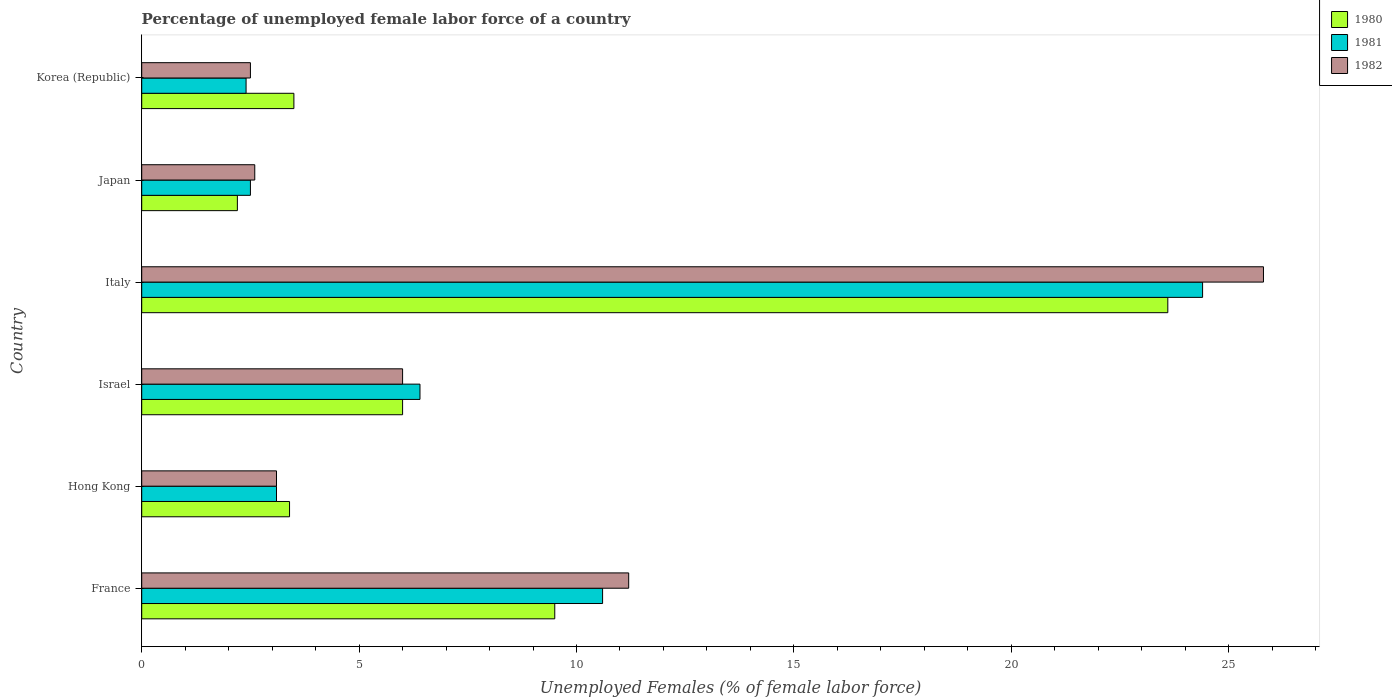How many different coloured bars are there?
Offer a very short reply. 3. How many groups of bars are there?
Provide a succinct answer. 6. What is the label of the 5th group of bars from the top?
Give a very brief answer. Hong Kong. In how many cases, is the number of bars for a given country not equal to the number of legend labels?
Ensure brevity in your answer.  0. Across all countries, what is the maximum percentage of unemployed female labor force in 1981?
Make the answer very short. 24.4. Across all countries, what is the minimum percentage of unemployed female labor force in 1981?
Your answer should be compact. 2.4. What is the total percentage of unemployed female labor force in 1980 in the graph?
Ensure brevity in your answer.  48.2. What is the difference between the percentage of unemployed female labor force in 1980 in Japan and that in Korea (Republic)?
Provide a succinct answer. -1.3. What is the difference between the percentage of unemployed female labor force in 1982 in Italy and the percentage of unemployed female labor force in 1981 in Hong Kong?
Offer a very short reply. 22.7. What is the average percentage of unemployed female labor force in 1981 per country?
Your response must be concise. 8.23. What is the difference between the percentage of unemployed female labor force in 1982 and percentage of unemployed female labor force in 1980 in Hong Kong?
Offer a terse response. -0.3. In how many countries, is the percentage of unemployed female labor force in 1980 greater than 18 %?
Your answer should be compact. 1. What is the ratio of the percentage of unemployed female labor force in 1980 in Hong Kong to that in Italy?
Your response must be concise. 0.14. Is the percentage of unemployed female labor force in 1980 in Japan less than that in Korea (Republic)?
Keep it short and to the point. Yes. Is the difference between the percentage of unemployed female labor force in 1982 in Italy and Korea (Republic) greater than the difference between the percentage of unemployed female labor force in 1980 in Italy and Korea (Republic)?
Make the answer very short. Yes. What is the difference between the highest and the second highest percentage of unemployed female labor force in 1982?
Give a very brief answer. 14.6. What is the difference between the highest and the lowest percentage of unemployed female labor force in 1980?
Your answer should be very brief. 21.4. In how many countries, is the percentage of unemployed female labor force in 1982 greater than the average percentage of unemployed female labor force in 1982 taken over all countries?
Your response must be concise. 2. What does the 1st bar from the top in France represents?
Provide a succinct answer. 1982. Is it the case that in every country, the sum of the percentage of unemployed female labor force in 1981 and percentage of unemployed female labor force in 1980 is greater than the percentage of unemployed female labor force in 1982?
Provide a succinct answer. Yes. Are the values on the major ticks of X-axis written in scientific E-notation?
Provide a short and direct response. No. Does the graph contain grids?
Provide a short and direct response. No. Where does the legend appear in the graph?
Give a very brief answer. Top right. What is the title of the graph?
Provide a succinct answer. Percentage of unemployed female labor force of a country. Does "2000" appear as one of the legend labels in the graph?
Your answer should be compact. No. What is the label or title of the X-axis?
Make the answer very short. Unemployed Females (% of female labor force). What is the label or title of the Y-axis?
Provide a short and direct response. Country. What is the Unemployed Females (% of female labor force) in 1980 in France?
Ensure brevity in your answer.  9.5. What is the Unemployed Females (% of female labor force) in 1981 in France?
Offer a very short reply. 10.6. What is the Unemployed Females (% of female labor force) of 1982 in France?
Your answer should be compact. 11.2. What is the Unemployed Females (% of female labor force) in 1980 in Hong Kong?
Keep it short and to the point. 3.4. What is the Unemployed Females (% of female labor force) of 1981 in Hong Kong?
Make the answer very short. 3.1. What is the Unemployed Females (% of female labor force) in 1982 in Hong Kong?
Your answer should be very brief. 3.1. What is the Unemployed Females (% of female labor force) in 1981 in Israel?
Your answer should be very brief. 6.4. What is the Unemployed Females (% of female labor force) of 1982 in Israel?
Your answer should be very brief. 6. What is the Unemployed Females (% of female labor force) in 1980 in Italy?
Give a very brief answer. 23.6. What is the Unemployed Females (% of female labor force) of 1981 in Italy?
Provide a short and direct response. 24.4. What is the Unemployed Females (% of female labor force) of 1982 in Italy?
Give a very brief answer. 25.8. What is the Unemployed Females (% of female labor force) of 1980 in Japan?
Your answer should be very brief. 2.2. What is the Unemployed Females (% of female labor force) of 1982 in Japan?
Offer a terse response. 2.6. What is the Unemployed Females (% of female labor force) of 1980 in Korea (Republic)?
Give a very brief answer. 3.5. What is the Unemployed Females (% of female labor force) in 1981 in Korea (Republic)?
Provide a succinct answer. 2.4. Across all countries, what is the maximum Unemployed Females (% of female labor force) in 1980?
Make the answer very short. 23.6. Across all countries, what is the maximum Unemployed Females (% of female labor force) of 1981?
Offer a very short reply. 24.4. Across all countries, what is the maximum Unemployed Females (% of female labor force) of 1982?
Ensure brevity in your answer.  25.8. Across all countries, what is the minimum Unemployed Females (% of female labor force) in 1980?
Your answer should be very brief. 2.2. Across all countries, what is the minimum Unemployed Females (% of female labor force) of 1981?
Ensure brevity in your answer.  2.4. Across all countries, what is the minimum Unemployed Females (% of female labor force) in 1982?
Ensure brevity in your answer.  2.5. What is the total Unemployed Females (% of female labor force) of 1980 in the graph?
Keep it short and to the point. 48.2. What is the total Unemployed Females (% of female labor force) of 1981 in the graph?
Offer a very short reply. 49.4. What is the total Unemployed Females (% of female labor force) of 1982 in the graph?
Your response must be concise. 51.2. What is the difference between the Unemployed Females (% of female labor force) of 1982 in France and that in Hong Kong?
Provide a short and direct response. 8.1. What is the difference between the Unemployed Females (% of female labor force) of 1981 in France and that in Israel?
Your response must be concise. 4.2. What is the difference between the Unemployed Females (% of female labor force) in 1980 in France and that in Italy?
Provide a short and direct response. -14.1. What is the difference between the Unemployed Females (% of female labor force) of 1981 in France and that in Italy?
Provide a short and direct response. -13.8. What is the difference between the Unemployed Females (% of female labor force) of 1982 in France and that in Italy?
Give a very brief answer. -14.6. What is the difference between the Unemployed Females (% of female labor force) of 1981 in France and that in Japan?
Offer a terse response. 8.1. What is the difference between the Unemployed Females (% of female labor force) in 1980 in France and that in Korea (Republic)?
Offer a very short reply. 6. What is the difference between the Unemployed Females (% of female labor force) in 1981 in France and that in Korea (Republic)?
Ensure brevity in your answer.  8.2. What is the difference between the Unemployed Females (% of female labor force) of 1980 in Hong Kong and that in Israel?
Your response must be concise. -2.6. What is the difference between the Unemployed Females (% of female labor force) of 1980 in Hong Kong and that in Italy?
Offer a very short reply. -20.2. What is the difference between the Unemployed Females (% of female labor force) in 1981 in Hong Kong and that in Italy?
Your answer should be very brief. -21.3. What is the difference between the Unemployed Females (% of female labor force) in 1982 in Hong Kong and that in Italy?
Make the answer very short. -22.7. What is the difference between the Unemployed Females (% of female labor force) of 1980 in Hong Kong and that in Japan?
Offer a terse response. 1.2. What is the difference between the Unemployed Females (% of female labor force) of 1981 in Hong Kong and that in Korea (Republic)?
Keep it short and to the point. 0.7. What is the difference between the Unemployed Females (% of female labor force) of 1982 in Hong Kong and that in Korea (Republic)?
Make the answer very short. 0.6. What is the difference between the Unemployed Females (% of female labor force) of 1980 in Israel and that in Italy?
Your response must be concise. -17.6. What is the difference between the Unemployed Females (% of female labor force) in 1981 in Israel and that in Italy?
Make the answer very short. -18. What is the difference between the Unemployed Females (% of female labor force) in 1982 in Israel and that in Italy?
Ensure brevity in your answer.  -19.8. What is the difference between the Unemployed Females (% of female labor force) of 1980 in Israel and that in Japan?
Ensure brevity in your answer.  3.8. What is the difference between the Unemployed Females (% of female labor force) of 1982 in Israel and that in Japan?
Provide a succinct answer. 3.4. What is the difference between the Unemployed Females (% of female labor force) in 1980 in Israel and that in Korea (Republic)?
Make the answer very short. 2.5. What is the difference between the Unemployed Females (% of female labor force) of 1982 in Israel and that in Korea (Republic)?
Make the answer very short. 3.5. What is the difference between the Unemployed Females (% of female labor force) of 1980 in Italy and that in Japan?
Provide a succinct answer. 21.4. What is the difference between the Unemployed Females (% of female labor force) in 1981 in Italy and that in Japan?
Provide a succinct answer. 21.9. What is the difference between the Unemployed Females (% of female labor force) of 1982 in Italy and that in Japan?
Your answer should be very brief. 23.2. What is the difference between the Unemployed Females (% of female labor force) in 1980 in Italy and that in Korea (Republic)?
Make the answer very short. 20.1. What is the difference between the Unemployed Females (% of female labor force) in 1982 in Italy and that in Korea (Republic)?
Ensure brevity in your answer.  23.3. What is the difference between the Unemployed Females (% of female labor force) in 1980 in Japan and that in Korea (Republic)?
Offer a very short reply. -1.3. What is the difference between the Unemployed Females (% of female labor force) of 1981 in Japan and that in Korea (Republic)?
Your answer should be compact. 0.1. What is the difference between the Unemployed Females (% of female labor force) of 1980 in France and the Unemployed Females (% of female labor force) of 1982 in Hong Kong?
Offer a terse response. 6.4. What is the difference between the Unemployed Females (% of female labor force) in 1981 in France and the Unemployed Females (% of female labor force) in 1982 in Hong Kong?
Your answer should be very brief. 7.5. What is the difference between the Unemployed Females (% of female labor force) in 1980 in France and the Unemployed Females (% of female labor force) in 1981 in Italy?
Your answer should be compact. -14.9. What is the difference between the Unemployed Females (% of female labor force) in 1980 in France and the Unemployed Females (% of female labor force) in 1982 in Italy?
Keep it short and to the point. -16.3. What is the difference between the Unemployed Females (% of female labor force) in 1981 in France and the Unemployed Females (% of female labor force) in 1982 in Italy?
Your answer should be compact. -15.2. What is the difference between the Unemployed Females (% of female labor force) in 1980 in France and the Unemployed Females (% of female labor force) in 1982 in Korea (Republic)?
Keep it short and to the point. 7. What is the difference between the Unemployed Females (% of female labor force) in 1980 in Hong Kong and the Unemployed Females (% of female labor force) in 1982 in Israel?
Give a very brief answer. -2.6. What is the difference between the Unemployed Females (% of female labor force) in 1980 in Hong Kong and the Unemployed Females (% of female labor force) in 1982 in Italy?
Provide a succinct answer. -22.4. What is the difference between the Unemployed Females (% of female labor force) of 1981 in Hong Kong and the Unemployed Females (% of female labor force) of 1982 in Italy?
Your answer should be compact. -22.7. What is the difference between the Unemployed Females (% of female labor force) in 1980 in Hong Kong and the Unemployed Females (% of female labor force) in 1982 in Japan?
Keep it short and to the point. 0.8. What is the difference between the Unemployed Females (% of female labor force) in 1980 in Israel and the Unemployed Females (% of female labor force) in 1981 in Italy?
Provide a short and direct response. -18.4. What is the difference between the Unemployed Females (% of female labor force) in 1980 in Israel and the Unemployed Females (% of female labor force) in 1982 in Italy?
Keep it short and to the point. -19.8. What is the difference between the Unemployed Females (% of female labor force) of 1981 in Israel and the Unemployed Females (% of female labor force) of 1982 in Italy?
Give a very brief answer. -19.4. What is the difference between the Unemployed Females (% of female labor force) of 1980 in Israel and the Unemployed Females (% of female labor force) of 1982 in Japan?
Provide a short and direct response. 3.4. What is the difference between the Unemployed Females (% of female labor force) in 1981 in Israel and the Unemployed Females (% of female labor force) in 1982 in Japan?
Provide a succinct answer. 3.8. What is the difference between the Unemployed Females (% of female labor force) in 1980 in Israel and the Unemployed Females (% of female labor force) in 1981 in Korea (Republic)?
Your response must be concise. 3.6. What is the difference between the Unemployed Females (% of female labor force) of 1980 in Israel and the Unemployed Females (% of female labor force) of 1982 in Korea (Republic)?
Ensure brevity in your answer.  3.5. What is the difference between the Unemployed Females (% of female labor force) of 1980 in Italy and the Unemployed Females (% of female labor force) of 1981 in Japan?
Make the answer very short. 21.1. What is the difference between the Unemployed Females (% of female labor force) of 1980 in Italy and the Unemployed Females (% of female labor force) of 1982 in Japan?
Your response must be concise. 21. What is the difference between the Unemployed Females (% of female labor force) of 1981 in Italy and the Unemployed Females (% of female labor force) of 1982 in Japan?
Your answer should be very brief. 21.8. What is the difference between the Unemployed Females (% of female labor force) of 1980 in Italy and the Unemployed Females (% of female labor force) of 1981 in Korea (Republic)?
Provide a short and direct response. 21.2. What is the difference between the Unemployed Females (% of female labor force) in 1980 in Italy and the Unemployed Females (% of female labor force) in 1982 in Korea (Republic)?
Provide a short and direct response. 21.1. What is the difference between the Unemployed Females (% of female labor force) in 1981 in Italy and the Unemployed Females (% of female labor force) in 1982 in Korea (Republic)?
Make the answer very short. 21.9. What is the difference between the Unemployed Females (% of female labor force) of 1980 in Japan and the Unemployed Females (% of female labor force) of 1981 in Korea (Republic)?
Provide a succinct answer. -0.2. What is the difference between the Unemployed Females (% of female labor force) in 1980 in Japan and the Unemployed Females (% of female labor force) in 1982 in Korea (Republic)?
Give a very brief answer. -0.3. What is the difference between the Unemployed Females (% of female labor force) of 1981 in Japan and the Unemployed Females (% of female labor force) of 1982 in Korea (Republic)?
Your answer should be compact. 0. What is the average Unemployed Females (% of female labor force) in 1980 per country?
Provide a succinct answer. 8.03. What is the average Unemployed Females (% of female labor force) in 1981 per country?
Make the answer very short. 8.23. What is the average Unemployed Females (% of female labor force) of 1982 per country?
Your answer should be compact. 8.53. What is the difference between the Unemployed Females (% of female labor force) of 1980 and Unemployed Females (% of female labor force) of 1981 in France?
Keep it short and to the point. -1.1. What is the difference between the Unemployed Females (% of female labor force) of 1980 and Unemployed Females (% of female labor force) of 1982 in France?
Your response must be concise. -1.7. What is the difference between the Unemployed Females (% of female labor force) of 1981 and Unemployed Females (% of female labor force) of 1982 in France?
Your response must be concise. -0.6. What is the difference between the Unemployed Females (% of female labor force) of 1981 and Unemployed Females (% of female labor force) of 1982 in Israel?
Your response must be concise. 0.4. What is the difference between the Unemployed Females (% of female labor force) of 1980 and Unemployed Females (% of female labor force) of 1982 in Italy?
Make the answer very short. -2.2. What is the difference between the Unemployed Females (% of female labor force) in 1981 and Unemployed Females (% of female labor force) in 1982 in Italy?
Make the answer very short. -1.4. What is the ratio of the Unemployed Females (% of female labor force) in 1980 in France to that in Hong Kong?
Provide a succinct answer. 2.79. What is the ratio of the Unemployed Females (% of female labor force) of 1981 in France to that in Hong Kong?
Give a very brief answer. 3.42. What is the ratio of the Unemployed Females (% of female labor force) of 1982 in France to that in Hong Kong?
Offer a terse response. 3.61. What is the ratio of the Unemployed Females (% of female labor force) in 1980 in France to that in Israel?
Keep it short and to the point. 1.58. What is the ratio of the Unemployed Females (% of female labor force) in 1981 in France to that in Israel?
Make the answer very short. 1.66. What is the ratio of the Unemployed Females (% of female labor force) of 1982 in France to that in Israel?
Offer a very short reply. 1.87. What is the ratio of the Unemployed Females (% of female labor force) in 1980 in France to that in Italy?
Your response must be concise. 0.4. What is the ratio of the Unemployed Females (% of female labor force) in 1981 in France to that in Italy?
Provide a short and direct response. 0.43. What is the ratio of the Unemployed Females (% of female labor force) of 1982 in France to that in Italy?
Offer a very short reply. 0.43. What is the ratio of the Unemployed Females (% of female labor force) of 1980 in France to that in Japan?
Give a very brief answer. 4.32. What is the ratio of the Unemployed Females (% of female labor force) of 1981 in France to that in Japan?
Provide a succinct answer. 4.24. What is the ratio of the Unemployed Females (% of female labor force) of 1982 in France to that in Japan?
Your answer should be very brief. 4.31. What is the ratio of the Unemployed Females (% of female labor force) in 1980 in France to that in Korea (Republic)?
Ensure brevity in your answer.  2.71. What is the ratio of the Unemployed Females (% of female labor force) in 1981 in France to that in Korea (Republic)?
Your answer should be compact. 4.42. What is the ratio of the Unemployed Females (% of female labor force) in 1982 in France to that in Korea (Republic)?
Give a very brief answer. 4.48. What is the ratio of the Unemployed Females (% of female labor force) of 1980 in Hong Kong to that in Israel?
Provide a succinct answer. 0.57. What is the ratio of the Unemployed Females (% of female labor force) of 1981 in Hong Kong to that in Israel?
Your answer should be very brief. 0.48. What is the ratio of the Unemployed Females (% of female labor force) in 1982 in Hong Kong to that in Israel?
Offer a terse response. 0.52. What is the ratio of the Unemployed Females (% of female labor force) of 1980 in Hong Kong to that in Italy?
Provide a succinct answer. 0.14. What is the ratio of the Unemployed Females (% of female labor force) of 1981 in Hong Kong to that in Italy?
Keep it short and to the point. 0.13. What is the ratio of the Unemployed Females (% of female labor force) of 1982 in Hong Kong to that in Italy?
Offer a terse response. 0.12. What is the ratio of the Unemployed Females (% of female labor force) of 1980 in Hong Kong to that in Japan?
Offer a terse response. 1.55. What is the ratio of the Unemployed Females (% of female labor force) of 1981 in Hong Kong to that in Japan?
Give a very brief answer. 1.24. What is the ratio of the Unemployed Females (% of female labor force) in 1982 in Hong Kong to that in Japan?
Make the answer very short. 1.19. What is the ratio of the Unemployed Females (% of female labor force) of 1980 in Hong Kong to that in Korea (Republic)?
Keep it short and to the point. 0.97. What is the ratio of the Unemployed Females (% of female labor force) in 1981 in Hong Kong to that in Korea (Republic)?
Offer a terse response. 1.29. What is the ratio of the Unemployed Females (% of female labor force) of 1982 in Hong Kong to that in Korea (Republic)?
Offer a terse response. 1.24. What is the ratio of the Unemployed Females (% of female labor force) in 1980 in Israel to that in Italy?
Offer a terse response. 0.25. What is the ratio of the Unemployed Females (% of female labor force) in 1981 in Israel to that in Italy?
Offer a very short reply. 0.26. What is the ratio of the Unemployed Females (% of female labor force) of 1982 in Israel to that in Italy?
Your answer should be compact. 0.23. What is the ratio of the Unemployed Females (% of female labor force) of 1980 in Israel to that in Japan?
Make the answer very short. 2.73. What is the ratio of the Unemployed Females (% of female labor force) in 1981 in Israel to that in Japan?
Provide a succinct answer. 2.56. What is the ratio of the Unemployed Females (% of female labor force) in 1982 in Israel to that in Japan?
Offer a terse response. 2.31. What is the ratio of the Unemployed Females (% of female labor force) of 1980 in Israel to that in Korea (Republic)?
Your response must be concise. 1.71. What is the ratio of the Unemployed Females (% of female labor force) of 1981 in Israel to that in Korea (Republic)?
Offer a very short reply. 2.67. What is the ratio of the Unemployed Females (% of female labor force) in 1980 in Italy to that in Japan?
Give a very brief answer. 10.73. What is the ratio of the Unemployed Females (% of female labor force) of 1981 in Italy to that in Japan?
Make the answer very short. 9.76. What is the ratio of the Unemployed Females (% of female labor force) in 1982 in Italy to that in Japan?
Provide a succinct answer. 9.92. What is the ratio of the Unemployed Females (% of female labor force) in 1980 in Italy to that in Korea (Republic)?
Your answer should be compact. 6.74. What is the ratio of the Unemployed Females (% of female labor force) of 1981 in Italy to that in Korea (Republic)?
Your answer should be compact. 10.17. What is the ratio of the Unemployed Females (% of female labor force) in 1982 in Italy to that in Korea (Republic)?
Ensure brevity in your answer.  10.32. What is the ratio of the Unemployed Females (% of female labor force) in 1980 in Japan to that in Korea (Republic)?
Make the answer very short. 0.63. What is the ratio of the Unemployed Females (% of female labor force) of 1981 in Japan to that in Korea (Republic)?
Ensure brevity in your answer.  1.04. What is the ratio of the Unemployed Females (% of female labor force) of 1982 in Japan to that in Korea (Republic)?
Give a very brief answer. 1.04. What is the difference between the highest and the second highest Unemployed Females (% of female labor force) in 1981?
Your response must be concise. 13.8. What is the difference between the highest and the second highest Unemployed Females (% of female labor force) of 1982?
Offer a terse response. 14.6. What is the difference between the highest and the lowest Unemployed Females (% of female labor force) in 1980?
Give a very brief answer. 21.4. What is the difference between the highest and the lowest Unemployed Females (% of female labor force) of 1981?
Keep it short and to the point. 22. What is the difference between the highest and the lowest Unemployed Females (% of female labor force) of 1982?
Make the answer very short. 23.3. 